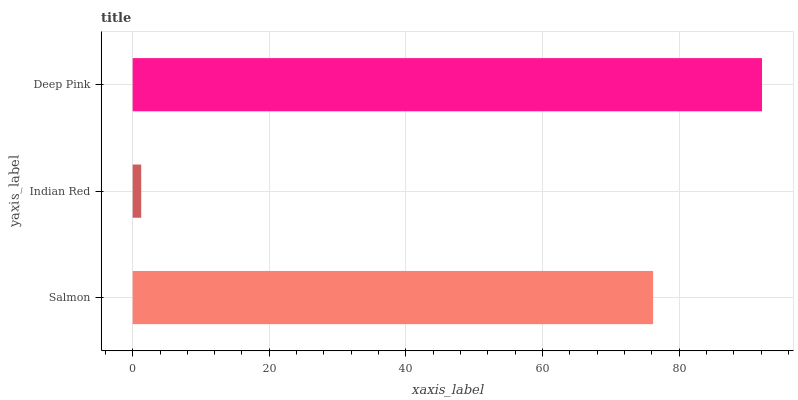Is Indian Red the minimum?
Answer yes or no. Yes. Is Deep Pink the maximum?
Answer yes or no. Yes. Is Deep Pink the minimum?
Answer yes or no. No. Is Indian Red the maximum?
Answer yes or no. No. Is Deep Pink greater than Indian Red?
Answer yes or no. Yes. Is Indian Red less than Deep Pink?
Answer yes or no. Yes. Is Indian Red greater than Deep Pink?
Answer yes or no. No. Is Deep Pink less than Indian Red?
Answer yes or no. No. Is Salmon the high median?
Answer yes or no. Yes. Is Salmon the low median?
Answer yes or no. Yes. Is Deep Pink the high median?
Answer yes or no. No. Is Deep Pink the low median?
Answer yes or no. No. 